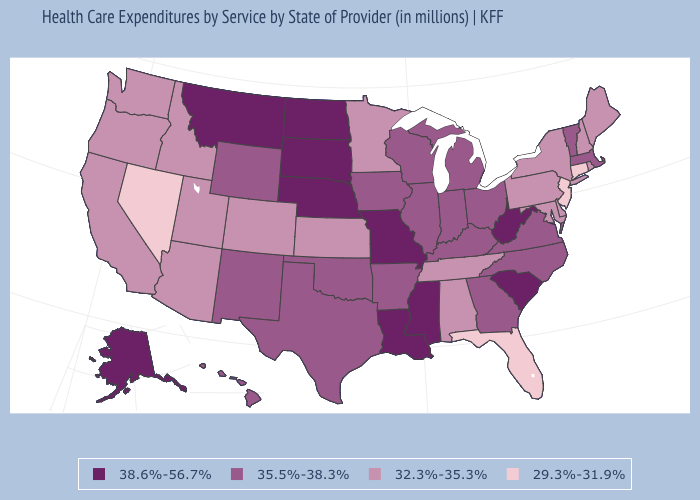Among the states that border Washington , which have the highest value?
Answer briefly. Idaho, Oregon. How many symbols are there in the legend?
Concise answer only. 4. Among the states that border Utah , which have the highest value?
Give a very brief answer. New Mexico, Wyoming. Does the map have missing data?
Concise answer only. No. Name the states that have a value in the range 38.6%-56.7%?
Give a very brief answer. Alaska, Louisiana, Mississippi, Missouri, Montana, Nebraska, North Dakota, South Carolina, South Dakota, West Virginia. Does Connecticut have the lowest value in the Northeast?
Quick response, please. Yes. What is the value of South Dakota?
Concise answer only. 38.6%-56.7%. Among the states that border New Hampshire , which have the highest value?
Write a very short answer. Massachusetts, Vermont. What is the lowest value in states that border Pennsylvania?
Answer briefly. 29.3%-31.9%. What is the value of Illinois?
Quick response, please. 35.5%-38.3%. What is the value of Kansas?
Write a very short answer. 32.3%-35.3%. Is the legend a continuous bar?
Short answer required. No. Does the map have missing data?
Give a very brief answer. No. Is the legend a continuous bar?
Answer briefly. No. Name the states that have a value in the range 35.5%-38.3%?
Short answer required. Arkansas, Georgia, Hawaii, Illinois, Indiana, Iowa, Kentucky, Massachusetts, Michigan, New Mexico, North Carolina, Ohio, Oklahoma, Texas, Vermont, Virginia, Wisconsin, Wyoming. 